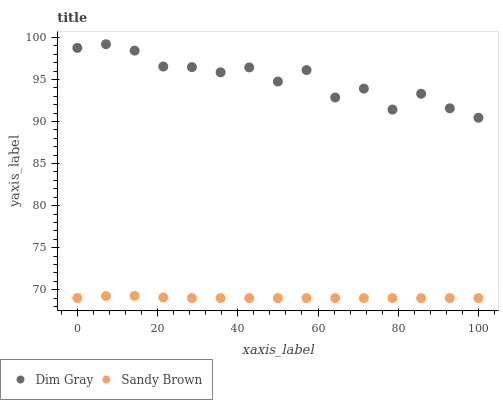Does Sandy Brown have the minimum area under the curve?
Answer yes or no. Yes. Does Dim Gray have the maximum area under the curve?
Answer yes or no. Yes. Does Sandy Brown have the maximum area under the curve?
Answer yes or no. No. Is Sandy Brown the smoothest?
Answer yes or no. Yes. Is Dim Gray the roughest?
Answer yes or no. Yes. Is Sandy Brown the roughest?
Answer yes or no. No. Does Sandy Brown have the lowest value?
Answer yes or no. Yes. Does Dim Gray have the highest value?
Answer yes or no. Yes. Does Sandy Brown have the highest value?
Answer yes or no. No. Is Sandy Brown less than Dim Gray?
Answer yes or no. Yes. Is Dim Gray greater than Sandy Brown?
Answer yes or no. Yes. Does Sandy Brown intersect Dim Gray?
Answer yes or no. No. 